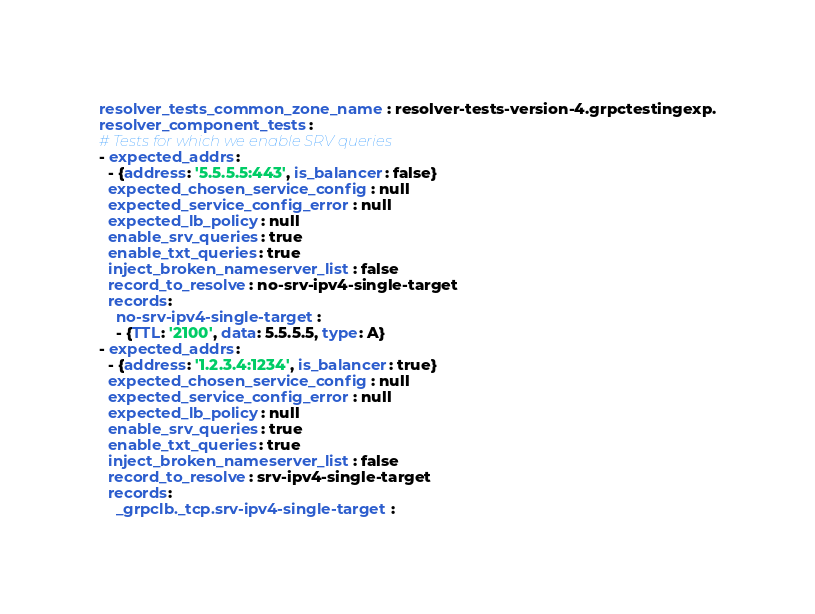<code> <loc_0><loc_0><loc_500><loc_500><_YAML_>resolver_tests_common_zone_name: resolver-tests-version-4.grpctestingexp.
resolver_component_tests:
# Tests for which we enable SRV queries
- expected_addrs:
  - {address: '5.5.5.5:443', is_balancer: false}
  expected_chosen_service_config: null
  expected_service_config_error: null
  expected_lb_policy: null
  enable_srv_queries: true
  enable_txt_queries: true
  inject_broken_nameserver_list: false
  record_to_resolve: no-srv-ipv4-single-target
  records:
    no-srv-ipv4-single-target:
    - {TTL: '2100', data: 5.5.5.5, type: A}
- expected_addrs:
  - {address: '1.2.3.4:1234', is_balancer: true}
  expected_chosen_service_config: null
  expected_service_config_error: null
  expected_lb_policy: null
  enable_srv_queries: true
  enable_txt_queries: true
  inject_broken_nameserver_list: false
  record_to_resolve: srv-ipv4-single-target
  records:
    _grpclb._tcp.srv-ipv4-single-target:</code> 